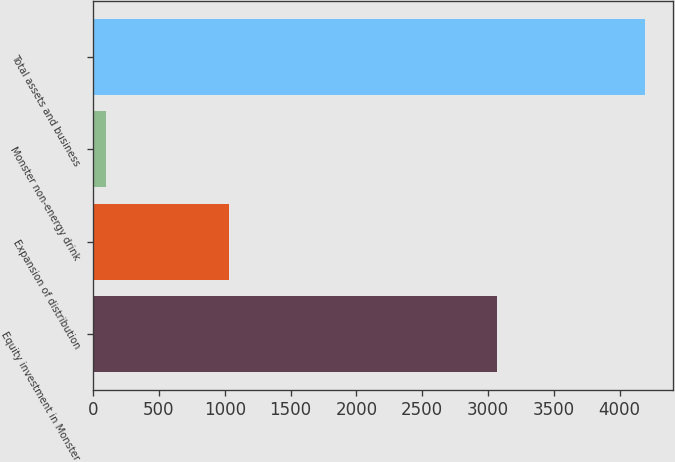Convert chart. <chart><loc_0><loc_0><loc_500><loc_500><bar_chart><fcel>Equity investment in Monster<fcel>Expansion of distribution<fcel>Monster non-energy drink<fcel>Total assets and business<nl><fcel>3066<fcel>1035<fcel>95<fcel>4196<nl></chart> 